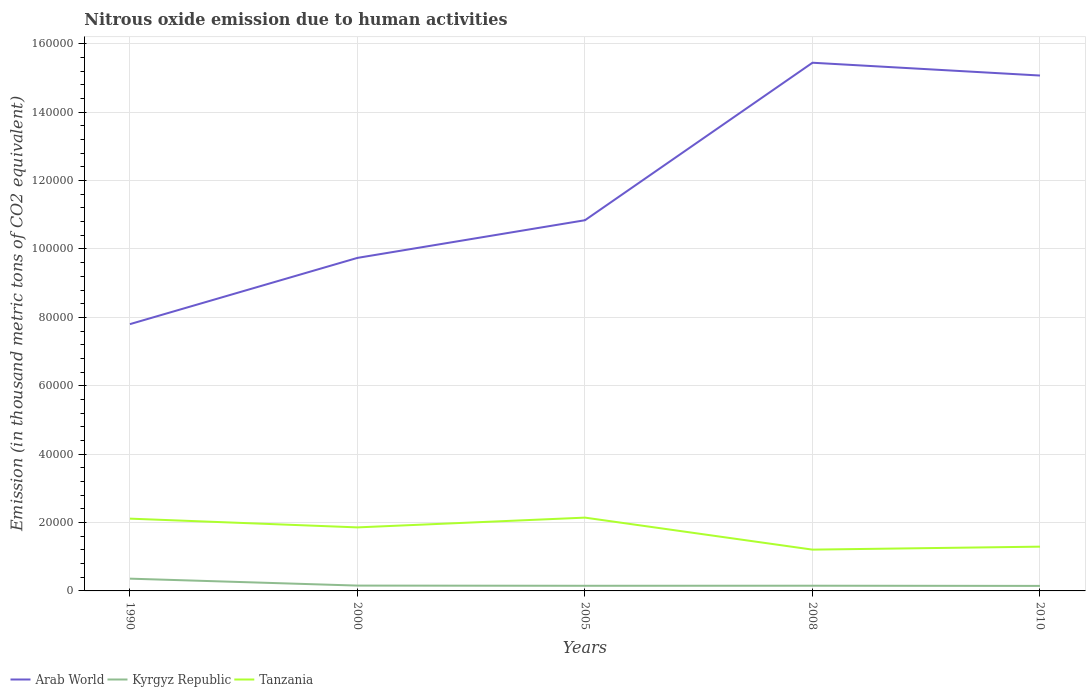How many different coloured lines are there?
Your answer should be compact. 3. Is the number of lines equal to the number of legend labels?
Your answer should be very brief. Yes. Across all years, what is the maximum amount of nitrous oxide emitted in Tanzania?
Your answer should be very brief. 1.21e+04. In which year was the amount of nitrous oxide emitted in Arab World maximum?
Ensure brevity in your answer.  1990. What is the total amount of nitrous oxide emitted in Tanzania in the graph?
Your answer should be very brief. 6504.6. What is the difference between the highest and the second highest amount of nitrous oxide emitted in Tanzania?
Keep it short and to the point. 9361.8. What is the difference between the highest and the lowest amount of nitrous oxide emitted in Kyrgyz Republic?
Provide a short and direct response. 1. How many lines are there?
Ensure brevity in your answer.  3. How many years are there in the graph?
Your response must be concise. 5. What is the difference between two consecutive major ticks on the Y-axis?
Keep it short and to the point. 2.00e+04. Are the values on the major ticks of Y-axis written in scientific E-notation?
Your answer should be very brief. No. Where does the legend appear in the graph?
Your answer should be very brief. Bottom left. What is the title of the graph?
Ensure brevity in your answer.  Nitrous oxide emission due to human activities. What is the label or title of the Y-axis?
Your response must be concise. Emission (in thousand metric tons of CO2 equivalent). What is the Emission (in thousand metric tons of CO2 equivalent) in Arab World in 1990?
Offer a terse response. 7.80e+04. What is the Emission (in thousand metric tons of CO2 equivalent) of Kyrgyz Republic in 1990?
Provide a succinct answer. 3586.5. What is the Emission (in thousand metric tons of CO2 equivalent) in Tanzania in 1990?
Your answer should be compact. 2.11e+04. What is the Emission (in thousand metric tons of CO2 equivalent) in Arab World in 2000?
Provide a short and direct response. 9.74e+04. What is the Emission (in thousand metric tons of CO2 equivalent) in Kyrgyz Republic in 2000?
Give a very brief answer. 1559.1. What is the Emission (in thousand metric tons of CO2 equivalent) of Tanzania in 2000?
Your answer should be very brief. 1.86e+04. What is the Emission (in thousand metric tons of CO2 equivalent) in Arab World in 2005?
Ensure brevity in your answer.  1.08e+05. What is the Emission (in thousand metric tons of CO2 equivalent) in Kyrgyz Republic in 2005?
Give a very brief answer. 1504.3. What is the Emission (in thousand metric tons of CO2 equivalent) of Tanzania in 2005?
Give a very brief answer. 2.14e+04. What is the Emission (in thousand metric tons of CO2 equivalent) in Arab World in 2008?
Your answer should be compact. 1.54e+05. What is the Emission (in thousand metric tons of CO2 equivalent) in Kyrgyz Republic in 2008?
Provide a short and direct response. 1519.3. What is the Emission (in thousand metric tons of CO2 equivalent) in Tanzania in 2008?
Give a very brief answer. 1.21e+04. What is the Emission (in thousand metric tons of CO2 equivalent) of Arab World in 2010?
Offer a terse response. 1.51e+05. What is the Emission (in thousand metric tons of CO2 equivalent) of Kyrgyz Republic in 2010?
Keep it short and to the point. 1465. What is the Emission (in thousand metric tons of CO2 equivalent) of Tanzania in 2010?
Give a very brief answer. 1.29e+04. Across all years, what is the maximum Emission (in thousand metric tons of CO2 equivalent) of Arab World?
Offer a very short reply. 1.54e+05. Across all years, what is the maximum Emission (in thousand metric tons of CO2 equivalent) of Kyrgyz Republic?
Your response must be concise. 3586.5. Across all years, what is the maximum Emission (in thousand metric tons of CO2 equivalent) in Tanzania?
Your response must be concise. 2.14e+04. Across all years, what is the minimum Emission (in thousand metric tons of CO2 equivalent) in Arab World?
Your answer should be compact. 7.80e+04. Across all years, what is the minimum Emission (in thousand metric tons of CO2 equivalent) in Kyrgyz Republic?
Provide a succinct answer. 1465. Across all years, what is the minimum Emission (in thousand metric tons of CO2 equivalent) of Tanzania?
Provide a short and direct response. 1.21e+04. What is the total Emission (in thousand metric tons of CO2 equivalent) in Arab World in the graph?
Keep it short and to the point. 5.89e+05. What is the total Emission (in thousand metric tons of CO2 equivalent) of Kyrgyz Republic in the graph?
Ensure brevity in your answer.  9634.2. What is the total Emission (in thousand metric tons of CO2 equivalent) of Tanzania in the graph?
Offer a terse response. 8.62e+04. What is the difference between the Emission (in thousand metric tons of CO2 equivalent) of Arab World in 1990 and that in 2000?
Your response must be concise. -1.94e+04. What is the difference between the Emission (in thousand metric tons of CO2 equivalent) of Kyrgyz Republic in 1990 and that in 2000?
Offer a terse response. 2027.4. What is the difference between the Emission (in thousand metric tons of CO2 equivalent) in Tanzania in 1990 and that in 2000?
Provide a succinct answer. 2557. What is the difference between the Emission (in thousand metric tons of CO2 equivalent) in Arab World in 1990 and that in 2005?
Keep it short and to the point. -3.04e+04. What is the difference between the Emission (in thousand metric tons of CO2 equivalent) in Kyrgyz Republic in 1990 and that in 2005?
Provide a short and direct response. 2082.2. What is the difference between the Emission (in thousand metric tons of CO2 equivalent) of Tanzania in 1990 and that in 2005?
Provide a short and direct response. -300.2. What is the difference between the Emission (in thousand metric tons of CO2 equivalent) in Arab World in 1990 and that in 2008?
Make the answer very short. -7.64e+04. What is the difference between the Emission (in thousand metric tons of CO2 equivalent) in Kyrgyz Republic in 1990 and that in 2008?
Provide a succinct answer. 2067.2. What is the difference between the Emission (in thousand metric tons of CO2 equivalent) in Tanzania in 1990 and that in 2008?
Make the answer very short. 9061.6. What is the difference between the Emission (in thousand metric tons of CO2 equivalent) of Arab World in 1990 and that in 2010?
Ensure brevity in your answer.  -7.27e+04. What is the difference between the Emission (in thousand metric tons of CO2 equivalent) of Kyrgyz Republic in 1990 and that in 2010?
Your answer should be compact. 2121.5. What is the difference between the Emission (in thousand metric tons of CO2 equivalent) in Tanzania in 1990 and that in 2010?
Keep it short and to the point. 8189.7. What is the difference between the Emission (in thousand metric tons of CO2 equivalent) of Arab World in 2000 and that in 2005?
Offer a terse response. -1.10e+04. What is the difference between the Emission (in thousand metric tons of CO2 equivalent) of Kyrgyz Republic in 2000 and that in 2005?
Provide a short and direct response. 54.8. What is the difference between the Emission (in thousand metric tons of CO2 equivalent) in Tanzania in 2000 and that in 2005?
Your answer should be very brief. -2857.2. What is the difference between the Emission (in thousand metric tons of CO2 equivalent) of Arab World in 2000 and that in 2008?
Your answer should be very brief. -5.71e+04. What is the difference between the Emission (in thousand metric tons of CO2 equivalent) of Kyrgyz Republic in 2000 and that in 2008?
Provide a short and direct response. 39.8. What is the difference between the Emission (in thousand metric tons of CO2 equivalent) in Tanzania in 2000 and that in 2008?
Make the answer very short. 6504.6. What is the difference between the Emission (in thousand metric tons of CO2 equivalent) in Arab World in 2000 and that in 2010?
Offer a very short reply. -5.33e+04. What is the difference between the Emission (in thousand metric tons of CO2 equivalent) in Kyrgyz Republic in 2000 and that in 2010?
Ensure brevity in your answer.  94.1. What is the difference between the Emission (in thousand metric tons of CO2 equivalent) of Tanzania in 2000 and that in 2010?
Provide a succinct answer. 5632.7. What is the difference between the Emission (in thousand metric tons of CO2 equivalent) of Arab World in 2005 and that in 2008?
Provide a short and direct response. -4.61e+04. What is the difference between the Emission (in thousand metric tons of CO2 equivalent) in Kyrgyz Republic in 2005 and that in 2008?
Your answer should be compact. -15. What is the difference between the Emission (in thousand metric tons of CO2 equivalent) in Tanzania in 2005 and that in 2008?
Keep it short and to the point. 9361.8. What is the difference between the Emission (in thousand metric tons of CO2 equivalent) in Arab World in 2005 and that in 2010?
Make the answer very short. -4.23e+04. What is the difference between the Emission (in thousand metric tons of CO2 equivalent) in Kyrgyz Republic in 2005 and that in 2010?
Give a very brief answer. 39.3. What is the difference between the Emission (in thousand metric tons of CO2 equivalent) of Tanzania in 2005 and that in 2010?
Your response must be concise. 8489.9. What is the difference between the Emission (in thousand metric tons of CO2 equivalent) in Arab World in 2008 and that in 2010?
Provide a succinct answer. 3741.4. What is the difference between the Emission (in thousand metric tons of CO2 equivalent) in Kyrgyz Republic in 2008 and that in 2010?
Your response must be concise. 54.3. What is the difference between the Emission (in thousand metric tons of CO2 equivalent) of Tanzania in 2008 and that in 2010?
Ensure brevity in your answer.  -871.9. What is the difference between the Emission (in thousand metric tons of CO2 equivalent) of Arab World in 1990 and the Emission (in thousand metric tons of CO2 equivalent) of Kyrgyz Republic in 2000?
Give a very brief answer. 7.65e+04. What is the difference between the Emission (in thousand metric tons of CO2 equivalent) in Arab World in 1990 and the Emission (in thousand metric tons of CO2 equivalent) in Tanzania in 2000?
Your answer should be compact. 5.94e+04. What is the difference between the Emission (in thousand metric tons of CO2 equivalent) of Kyrgyz Republic in 1990 and the Emission (in thousand metric tons of CO2 equivalent) of Tanzania in 2000?
Offer a terse response. -1.50e+04. What is the difference between the Emission (in thousand metric tons of CO2 equivalent) in Arab World in 1990 and the Emission (in thousand metric tons of CO2 equivalent) in Kyrgyz Republic in 2005?
Your answer should be compact. 7.65e+04. What is the difference between the Emission (in thousand metric tons of CO2 equivalent) in Arab World in 1990 and the Emission (in thousand metric tons of CO2 equivalent) in Tanzania in 2005?
Keep it short and to the point. 5.66e+04. What is the difference between the Emission (in thousand metric tons of CO2 equivalent) of Kyrgyz Republic in 1990 and the Emission (in thousand metric tons of CO2 equivalent) of Tanzania in 2005?
Your response must be concise. -1.79e+04. What is the difference between the Emission (in thousand metric tons of CO2 equivalent) of Arab World in 1990 and the Emission (in thousand metric tons of CO2 equivalent) of Kyrgyz Republic in 2008?
Provide a short and direct response. 7.65e+04. What is the difference between the Emission (in thousand metric tons of CO2 equivalent) of Arab World in 1990 and the Emission (in thousand metric tons of CO2 equivalent) of Tanzania in 2008?
Your answer should be very brief. 6.59e+04. What is the difference between the Emission (in thousand metric tons of CO2 equivalent) in Kyrgyz Republic in 1990 and the Emission (in thousand metric tons of CO2 equivalent) in Tanzania in 2008?
Provide a short and direct response. -8489.1. What is the difference between the Emission (in thousand metric tons of CO2 equivalent) of Arab World in 1990 and the Emission (in thousand metric tons of CO2 equivalent) of Kyrgyz Republic in 2010?
Your answer should be very brief. 7.66e+04. What is the difference between the Emission (in thousand metric tons of CO2 equivalent) in Arab World in 1990 and the Emission (in thousand metric tons of CO2 equivalent) in Tanzania in 2010?
Keep it short and to the point. 6.51e+04. What is the difference between the Emission (in thousand metric tons of CO2 equivalent) in Kyrgyz Republic in 1990 and the Emission (in thousand metric tons of CO2 equivalent) in Tanzania in 2010?
Your response must be concise. -9361. What is the difference between the Emission (in thousand metric tons of CO2 equivalent) of Arab World in 2000 and the Emission (in thousand metric tons of CO2 equivalent) of Kyrgyz Republic in 2005?
Give a very brief answer. 9.59e+04. What is the difference between the Emission (in thousand metric tons of CO2 equivalent) of Arab World in 2000 and the Emission (in thousand metric tons of CO2 equivalent) of Tanzania in 2005?
Offer a terse response. 7.60e+04. What is the difference between the Emission (in thousand metric tons of CO2 equivalent) in Kyrgyz Republic in 2000 and the Emission (in thousand metric tons of CO2 equivalent) in Tanzania in 2005?
Make the answer very short. -1.99e+04. What is the difference between the Emission (in thousand metric tons of CO2 equivalent) in Arab World in 2000 and the Emission (in thousand metric tons of CO2 equivalent) in Kyrgyz Republic in 2008?
Your answer should be very brief. 9.59e+04. What is the difference between the Emission (in thousand metric tons of CO2 equivalent) in Arab World in 2000 and the Emission (in thousand metric tons of CO2 equivalent) in Tanzania in 2008?
Provide a succinct answer. 8.53e+04. What is the difference between the Emission (in thousand metric tons of CO2 equivalent) of Kyrgyz Republic in 2000 and the Emission (in thousand metric tons of CO2 equivalent) of Tanzania in 2008?
Ensure brevity in your answer.  -1.05e+04. What is the difference between the Emission (in thousand metric tons of CO2 equivalent) of Arab World in 2000 and the Emission (in thousand metric tons of CO2 equivalent) of Kyrgyz Republic in 2010?
Offer a very short reply. 9.59e+04. What is the difference between the Emission (in thousand metric tons of CO2 equivalent) in Arab World in 2000 and the Emission (in thousand metric tons of CO2 equivalent) in Tanzania in 2010?
Provide a succinct answer. 8.44e+04. What is the difference between the Emission (in thousand metric tons of CO2 equivalent) in Kyrgyz Republic in 2000 and the Emission (in thousand metric tons of CO2 equivalent) in Tanzania in 2010?
Your answer should be very brief. -1.14e+04. What is the difference between the Emission (in thousand metric tons of CO2 equivalent) in Arab World in 2005 and the Emission (in thousand metric tons of CO2 equivalent) in Kyrgyz Republic in 2008?
Your answer should be compact. 1.07e+05. What is the difference between the Emission (in thousand metric tons of CO2 equivalent) of Arab World in 2005 and the Emission (in thousand metric tons of CO2 equivalent) of Tanzania in 2008?
Your answer should be very brief. 9.63e+04. What is the difference between the Emission (in thousand metric tons of CO2 equivalent) of Kyrgyz Republic in 2005 and the Emission (in thousand metric tons of CO2 equivalent) of Tanzania in 2008?
Your answer should be compact. -1.06e+04. What is the difference between the Emission (in thousand metric tons of CO2 equivalent) in Arab World in 2005 and the Emission (in thousand metric tons of CO2 equivalent) in Kyrgyz Republic in 2010?
Offer a very short reply. 1.07e+05. What is the difference between the Emission (in thousand metric tons of CO2 equivalent) in Arab World in 2005 and the Emission (in thousand metric tons of CO2 equivalent) in Tanzania in 2010?
Your response must be concise. 9.55e+04. What is the difference between the Emission (in thousand metric tons of CO2 equivalent) of Kyrgyz Republic in 2005 and the Emission (in thousand metric tons of CO2 equivalent) of Tanzania in 2010?
Ensure brevity in your answer.  -1.14e+04. What is the difference between the Emission (in thousand metric tons of CO2 equivalent) in Arab World in 2008 and the Emission (in thousand metric tons of CO2 equivalent) in Kyrgyz Republic in 2010?
Your answer should be compact. 1.53e+05. What is the difference between the Emission (in thousand metric tons of CO2 equivalent) of Arab World in 2008 and the Emission (in thousand metric tons of CO2 equivalent) of Tanzania in 2010?
Your answer should be compact. 1.42e+05. What is the difference between the Emission (in thousand metric tons of CO2 equivalent) of Kyrgyz Republic in 2008 and the Emission (in thousand metric tons of CO2 equivalent) of Tanzania in 2010?
Provide a short and direct response. -1.14e+04. What is the average Emission (in thousand metric tons of CO2 equivalent) of Arab World per year?
Your answer should be compact. 1.18e+05. What is the average Emission (in thousand metric tons of CO2 equivalent) of Kyrgyz Republic per year?
Your answer should be very brief. 1926.84. What is the average Emission (in thousand metric tons of CO2 equivalent) in Tanzania per year?
Your response must be concise. 1.72e+04. In the year 1990, what is the difference between the Emission (in thousand metric tons of CO2 equivalent) in Arab World and Emission (in thousand metric tons of CO2 equivalent) in Kyrgyz Republic?
Keep it short and to the point. 7.44e+04. In the year 1990, what is the difference between the Emission (in thousand metric tons of CO2 equivalent) in Arab World and Emission (in thousand metric tons of CO2 equivalent) in Tanzania?
Provide a succinct answer. 5.69e+04. In the year 1990, what is the difference between the Emission (in thousand metric tons of CO2 equivalent) in Kyrgyz Republic and Emission (in thousand metric tons of CO2 equivalent) in Tanzania?
Make the answer very short. -1.76e+04. In the year 2000, what is the difference between the Emission (in thousand metric tons of CO2 equivalent) in Arab World and Emission (in thousand metric tons of CO2 equivalent) in Kyrgyz Republic?
Make the answer very short. 9.58e+04. In the year 2000, what is the difference between the Emission (in thousand metric tons of CO2 equivalent) of Arab World and Emission (in thousand metric tons of CO2 equivalent) of Tanzania?
Offer a terse response. 7.88e+04. In the year 2000, what is the difference between the Emission (in thousand metric tons of CO2 equivalent) of Kyrgyz Republic and Emission (in thousand metric tons of CO2 equivalent) of Tanzania?
Ensure brevity in your answer.  -1.70e+04. In the year 2005, what is the difference between the Emission (in thousand metric tons of CO2 equivalent) in Arab World and Emission (in thousand metric tons of CO2 equivalent) in Kyrgyz Republic?
Provide a short and direct response. 1.07e+05. In the year 2005, what is the difference between the Emission (in thousand metric tons of CO2 equivalent) of Arab World and Emission (in thousand metric tons of CO2 equivalent) of Tanzania?
Your response must be concise. 8.70e+04. In the year 2005, what is the difference between the Emission (in thousand metric tons of CO2 equivalent) of Kyrgyz Republic and Emission (in thousand metric tons of CO2 equivalent) of Tanzania?
Your answer should be compact. -1.99e+04. In the year 2008, what is the difference between the Emission (in thousand metric tons of CO2 equivalent) of Arab World and Emission (in thousand metric tons of CO2 equivalent) of Kyrgyz Republic?
Your response must be concise. 1.53e+05. In the year 2008, what is the difference between the Emission (in thousand metric tons of CO2 equivalent) in Arab World and Emission (in thousand metric tons of CO2 equivalent) in Tanzania?
Keep it short and to the point. 1.42e+05. In the year 2008, what is the difference between the Emission (in thousand metric tons of CO2 equivalent) of Kyrgyz Republic and Emission (in thousand metric tons of CO2 equivalent) of Tanzania?
Offer a very short reply. -1.06e+04. In the year 2010, what is the difference between the Emission (in thousand metric tons of CO2 equivalent) in Arab World and Emission (in thousand metric tons of CO2 equivalent) in Kyrgyz Republic?
Make the answer very short. 1.49e+05. In the year 2010, what is the difference between the Emission (in thousand metric tons of CO2 equivalent) in Arab World and Emission (in thousand metric tons of CO2 equivalent) in Tanzania?
Provide a succinct answer. 1.38e+05. In the year 2010, what is the difference between the Emission (in thousand metric tons of CO2 equivalent) in Kyrgyz Republic and Emission (in thousand metric tons of CO2 equivalent) in Tanzania?
Keep it short and to the point. -1.15e+04. What is the ratio of the Emission (in thousand metric tons of CO2 equivalent) of Arab World in 1990 to that in 2000?
Provide a succinct answer. 0.8. What is the ratio of the Emission (in thousand metric tons of CO2 equivalent) of Kyrgyz Republic in 1990 to that in 2000?
Your answer should be compact. 2.3. What is the ratio of the Emission (in thousand metric tons of CO2 equivalent) in Tanzania in 1990 to that in 2000?
Your answer should be very brief. 1.14. What is the ratio of the Emission (in thousand metric tons of CO2 equivalent) of Arab World in 1990 to that in 2005?
Your answer should be very brief. 0.72. What is the ratio of the Emission (in thousand metric tons of CO2 equivalent) in Kyrgyz Republic in 1990 to that in 2005?
Keep it short and to the point. 2.38. What is the ratio of the Emission (in thousand metric tons of CO2 equivalent) of Arab World in 1990 to that in 2008?
Offer a terse response. 0.51. What is the ratio of the Emission (in thousand metric tons of CO2 equivalent) of Kyrgyz Republic in 1990 to that in 2008?
Provide a succinct answer. 2.36. What is the ratio of the Emission (in thousand metric tons of CO2 equivalent) of Tanzania in 1990 to that in 2008?
Make the answer very short. 1.75. What is the ratio of the Emission (in thousand metric tons of CO2 equivalent) in Arab World in 1990 to that in 2010?
Offer a very short reply. 0.52. What is the ratio of the Emission (in thousand metric tons of CO2 equivalent) in Kyrgyz Republic in 1990 to that in 2010?
Your response must be concise. 2.45. What is the ratio of the Emission (in thousand metric tons of CO2 equivalent) in Tanzania in 1990 to that in 2010?
Offer a terse response. 1.63. What is the ratio of the Emission (in thousand metric tons of CO2 equivalent) of Arab World in 2000 to that in 2005?
Offer a terse response. 0.9. What is the ratio of the Emission (in thousand metric tons of CO2 equivalent) of Kyrgyz Republic in 2000 to that in 2005?
Offer a terse response. 1.04. What is the ratio of the Emission (in thousand metric tons of CO2 equivalent) of Tanzania in 2000 to that in 2005?
Your answer should be very brief. 0.87. What is the ratio of the Emission (in thousand metric tons of CO2 equivalent) in Arab World in 2000 to that in 2008?
Keep it short and to the point. 0.63. What is the ratio of the Emission (in thousand metric tons of CO2 equivalent) of Kyrgyz Republic in 2000 to that in 2008?
Make the answer very short. 1.03. What is the ratio of the Emission (in thousand metric tons of CO2 equivalent) in Tanzania in 2000 to that in 2008?
Keep it short and to the point. 1.54. What is the ratio of the Emission (in thousand metric tons of CO2 equivalent) in Arab World in 2000 to that in 2010?
Give a very brief answer. 0.65. What is the ratio of the Emission (in thousand metric tons of CO2 equivalent) of Kyrgyz Republic in 2000 to that in 2010?
Keep it short and to the point. 1.06. What is the ratio of the Emission (in thousand metric tons of CO2 equivalent) of Tanzania in 2000 to that in 2010?
Make the answer very short. 1.44. What is the ratio of the Emission (in thousand metric tons of CO2 equivalent) in Arab World in 2005 to that in 2008?
Make the answer very short. 0.7. What is the ratio of the Emission (in thousand metric tons of CO2 equivalent) in Tanzania in 2005 to that in 2008?
Give a very brief answer. 1.78. What is the ratio of the Emission (in thousand metric tons of CO2 equivalent) in Arab World in 2005 to that in 2010?
Ensure brevity in your answer.  0.72. What is the ratio of the Emission (in thousand metric tons of CO2 equivalent) of Kyrgyz Republic in 2005 to that in 2010?
Ensure brevity in your answer.  1.03. What is the ratio of the Emission (in thousand metric tons of CO2 equivalent) in Tanzania in 2005 to that in 2010?
Your response must be concise. 1.66. What is the ratio of the Emission (in thousand metric tons of CO2 equivalent) of Arab World in 2008 to that in 2010?
Offer a terse response. 1.02. What is the ratio of the Emission (in thousand metric tons of CO2 equivalent) of Kyrgyz Republic in 2008 to that in 2010?
Offer a terse response. 1.04. What is the ratio of the Emission (in thousand metric tons of CO2 equivalent) in Tanzania in 2008 to that in 2010?
Keep it short and to the point. 0.93. What is the difference between the highest and the second highest Emission (in thousand metric tons of CO2 equivalent) in Arab World?
Offer a very short reply. 3741.4. What is the difference between the highest and the second highest Emission (in thousand metric tons of CO2 equivalent) of Kyrgyz Republic?
Provide a succinct answer. 2027.4. What is the difference between the highest and the second highest Emission (in thousand metric tons of CO2 equivalent) in Tanzania?
Your answer should be compact. 300.2. What is the difference between the highest and the lowest Emission (in thousand metric tons of CO2 equivalent) of Arab World?
Offer a terse response. 7.64e+04. What is the difference between the highest and the lowest Emission (in thousand metric tons of CO2 equivalent) in Kyrgyz Republic?
Provide a succinct answer. 2121.5. What is the difference between the highest and the lowest Emission (in thousand metric tons of CO2 equivalent) of Tanzania?
Give a very brief answer. 9361.8. 